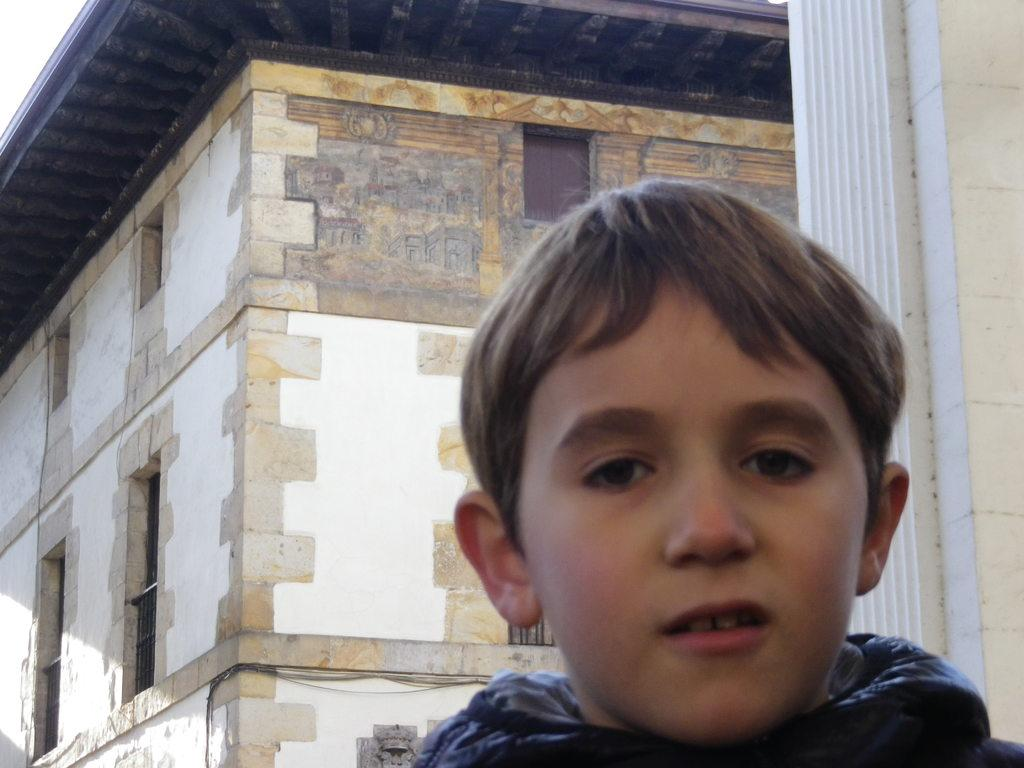Who or what is the main subject in the image? There is a person in the image. What is the person wearing? The person is wearing a black jacket. What can be seen in the background of the image? There is a building in the background of the image. What colors are used for the building? The building is in white and cream colors. What is visible above the building? The sky is visible in the background of the image. What color is the sky in the image? The sky is white in color. How many oranges are being held by the person in the image? There are no oranges present in the image. What type of blade is being used by the person in the image? There is no blade visible in the image. 